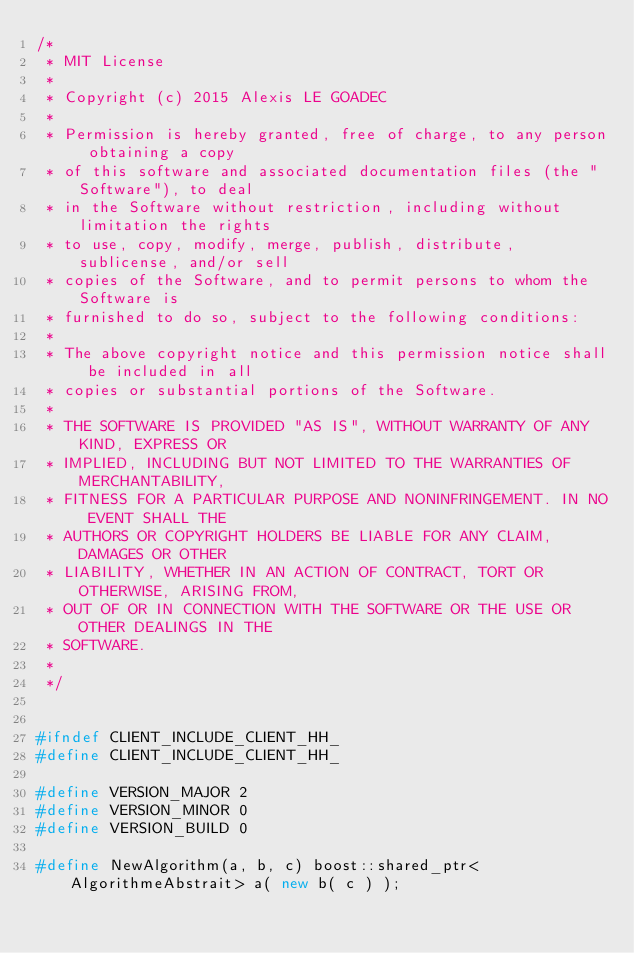Convert code to text. <code><loc_0><loc_0><loc_500><loc_500><_C++_>/*
 * MIT License
 * 
 * Copyright (c) 2015 Alexis LE GOADEC
 * 
 * Permission is hereby granted, free of charge, to any person obtaining a copy
 * of this software and associated documentation files (the "Software"), to deal
 * in the Software without restriction, including without limitation the rights
 * to use, copy, modify, merge, publish, distribute, sublicense, and/or sell
 * copies of the Software, and to permit persons to whom the Software is
 * furnished to do so, subject to the following conditions:
 * 
 * The above copyright notice and this permission notice shall be included in all
 * copies or substantial portions of the Software.
 * 
 * THE SOFTWARE IS PROVIDED "AS IS", WITHOUT WARRANTY OF ANY KIND, EXPRESS OR
 * IMPLIED, INCLUDING BUT NOT LIMITED TO THE WARRANTIES OF MERCHANTABILITY,
 * FITNESS FOR A PARTICULAR PURPOSE AND NONINFRINGEMENT. IN NO EVENT SHALL THE
 * AUTHORS OR COPYRIGHT HOLDERS BE LIABLE FOR ANY CLAIM, DAMAGES OR OTHER
 * LIABILITY, WHETHER IN AN ACTION OF CONTRACT, TORT OR OTHERWISE, ARISING FROM,
 * OUT OF OR IN CONNECTION WITH THE SOFTWARE OR THE USE OR OTHER DEALINGS IN THE
 * SOFTWARE.
 *
 */


#ifndef CLIENT_INCLUDE_CLIENT_HH_
#define CLIENT_INCLUDE_CLIENT_HH_

#define VERSION_MAJOR 2
#define VERSION_MINOR 0
#define VERSION_BUILD 0

#define NewAlgorithm(a, b, c) boost::shared_ptr<AlgorithmeAbstrait> a( new b( c ) );</code> 